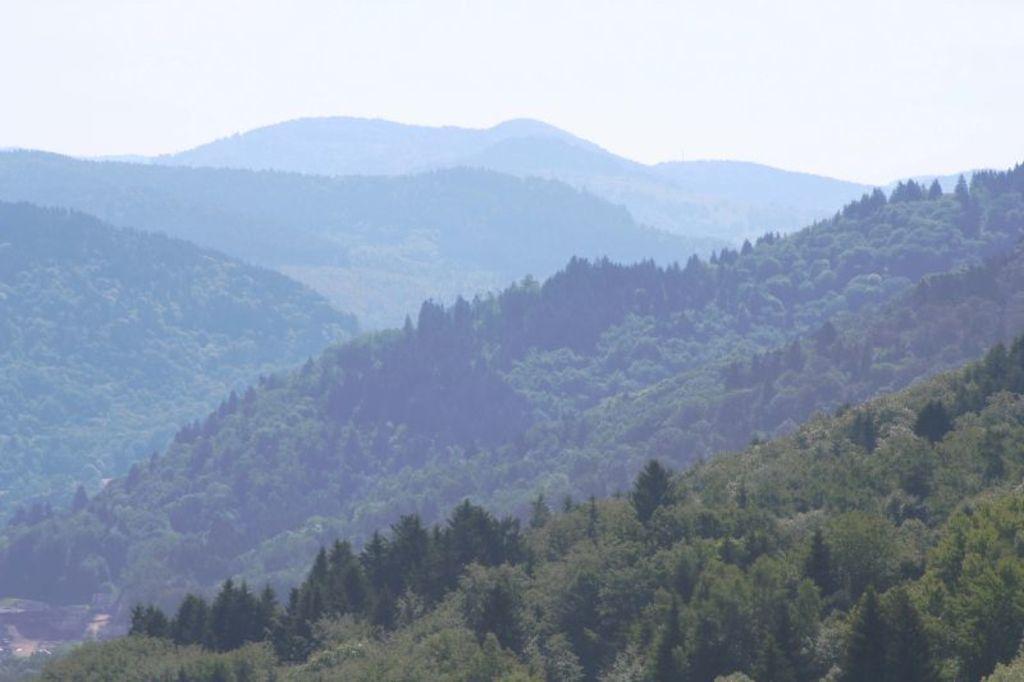Could you give a brief overview of what you see in this image? In this image I can see trees and hills. In the background I can see the sky. 